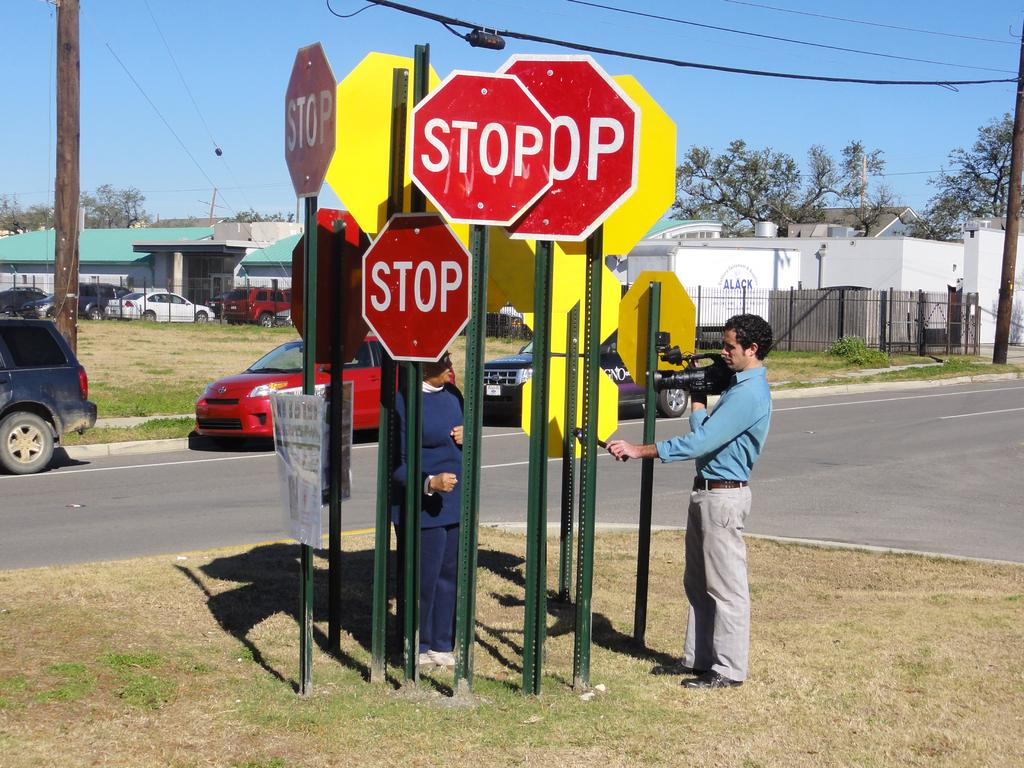<image>
Create a compact narrative representing the image presented. Several red stop signs clustered together at the street. 